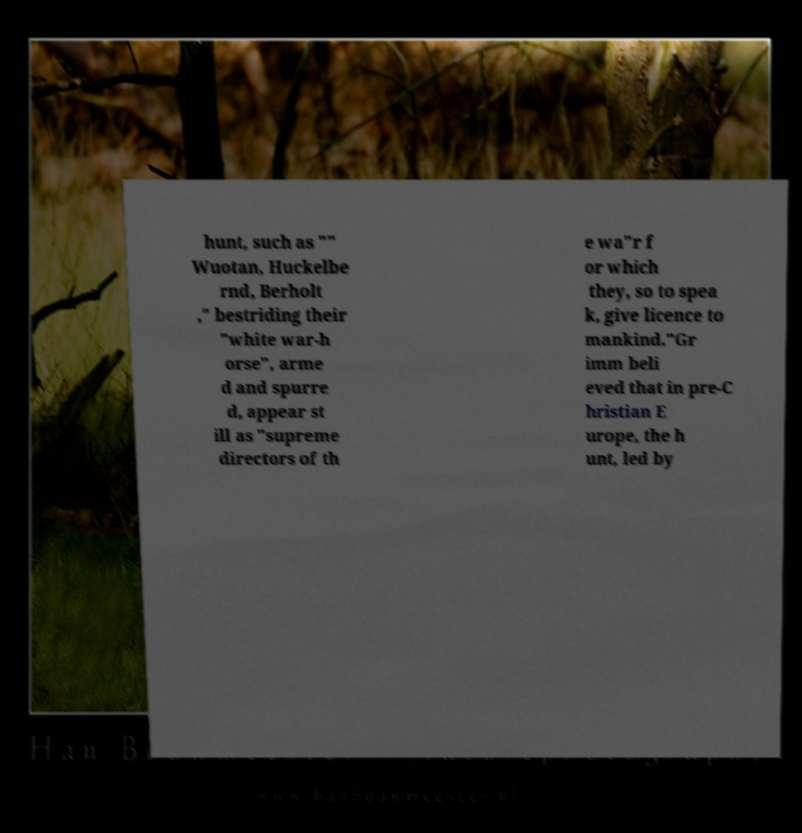Could you assist in decoding the text presented in this image and type it out clearly? hunt, such as "" Wuotan, Huckelbe rnd, Berholt ," bestriding their "white war-h orse", arme d and spurre d, appear st ill as "supreme directors of th e wa"r f or which they, so to spea k, give licence to mankind."Gr imm beli eved that in pre-C hristian E urope, the h unt, led by 